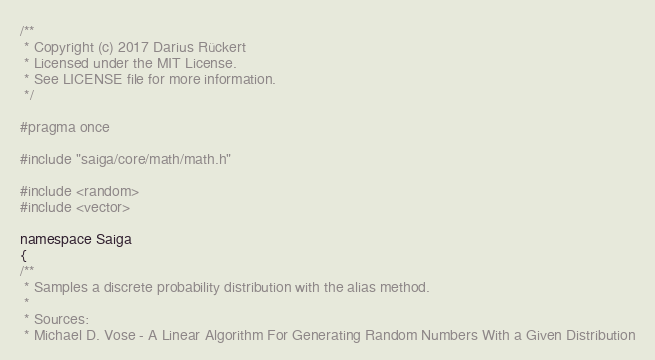Convert code to text. <code><loc_0><loc_0><loc_500><loc_500><_C_>/**
 * Copyright (c) 2017 Darius Rückert
 * Licensed under the MIT License.
 * See LICENSE file for more information.
 */

#pragma once

#include "saiga/core/math/math.h"

#include <random>
#include <vector>

namespace Saiga
{
/**
 * Samples a discrete probability distribution with the alias method.
 *
 * Sources:
 * Michael D. Vose - A Linear Algorithm For Generating Random Numbers With a Given Distribution</code> 